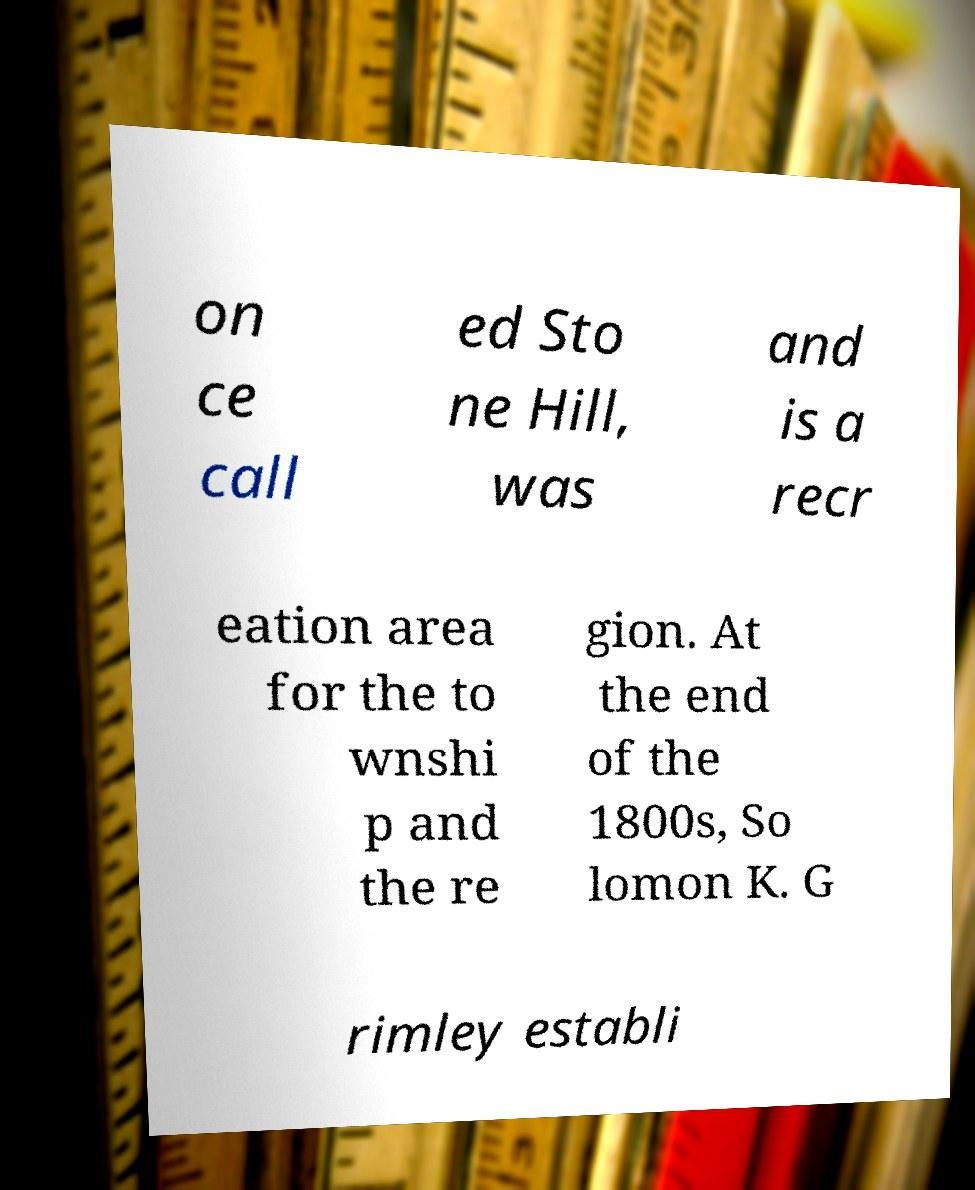For documentation purposes, I need the text within this image transcribed. Could you provide that? on ce call ed Sto ne Hill, was and is a recr eation area for the to wnshi p and the re gion. At the end of the 1800s, So lomon K. G rimley establi 